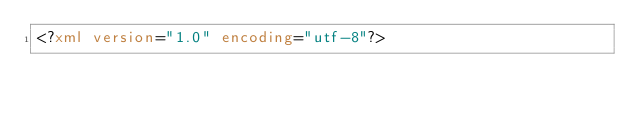Convert code to text. <code><loc_0><loc_0><loc_500><loc_500><_XML_><?xml version="1.0" encoding="utf-8"?></code> 